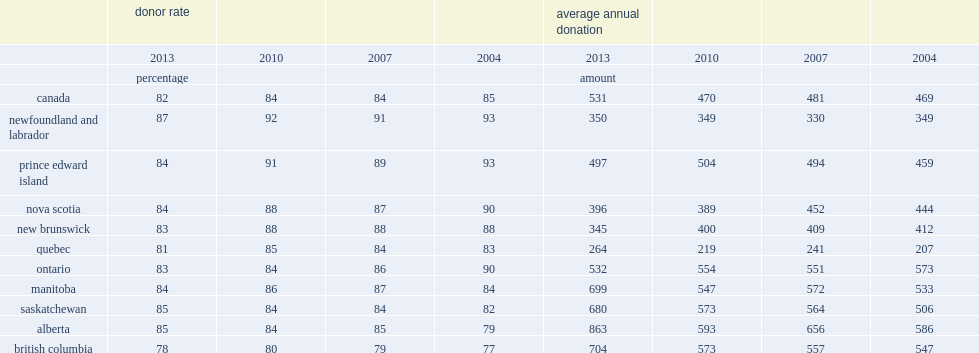Which province's proportion of canadians making a financial donation was highest in 2013? Newfoundland and labrador. Which province's proportion of canadians making a financial donation was lowest in 2013? British columbia. Which province's average donations were lowest in canada in 2013? Quebec. 